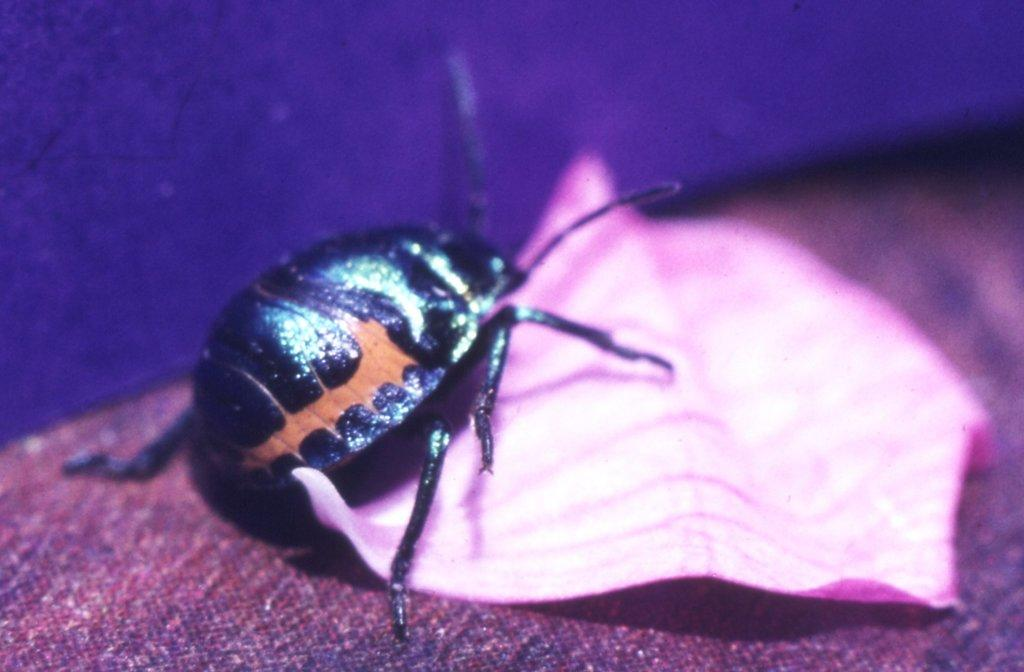What type of creature is present in the image? There is a bug in the image. What is the other object visible in the image? There is a cloth in the image. What is located at the bottom of the image? There is a mat at the bottom of the image. How does the bug grip onto the cloth in the image? The bug does not grip onto the cloth in the image; it is simply present on the cloth. What type of weather condition is depicted in the image? There is no indication of any weather condition in the image, as it only features a bug and a cloth. 